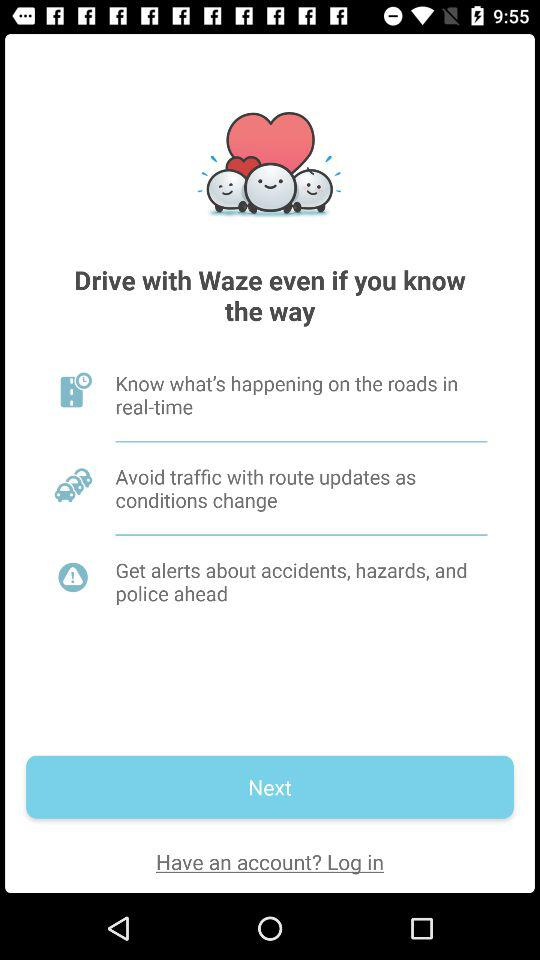What is the application name? The application name is "Waze". 